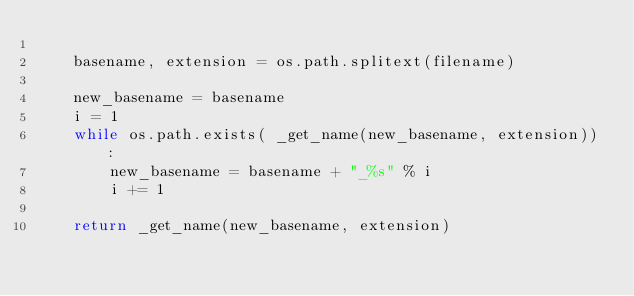<code> <loc_0><loc_0><loc_500><loc_500><_Python_>
    basename, extension = os.path.splitext(filename)

    new_basename = basename
    i = 1
    while os.path.exists( _get_name(new_basename, extension)) :
        new_basename = basename + "_%s" % i
        i += 1

    return _get_name(new_basename, extension)
</code> 